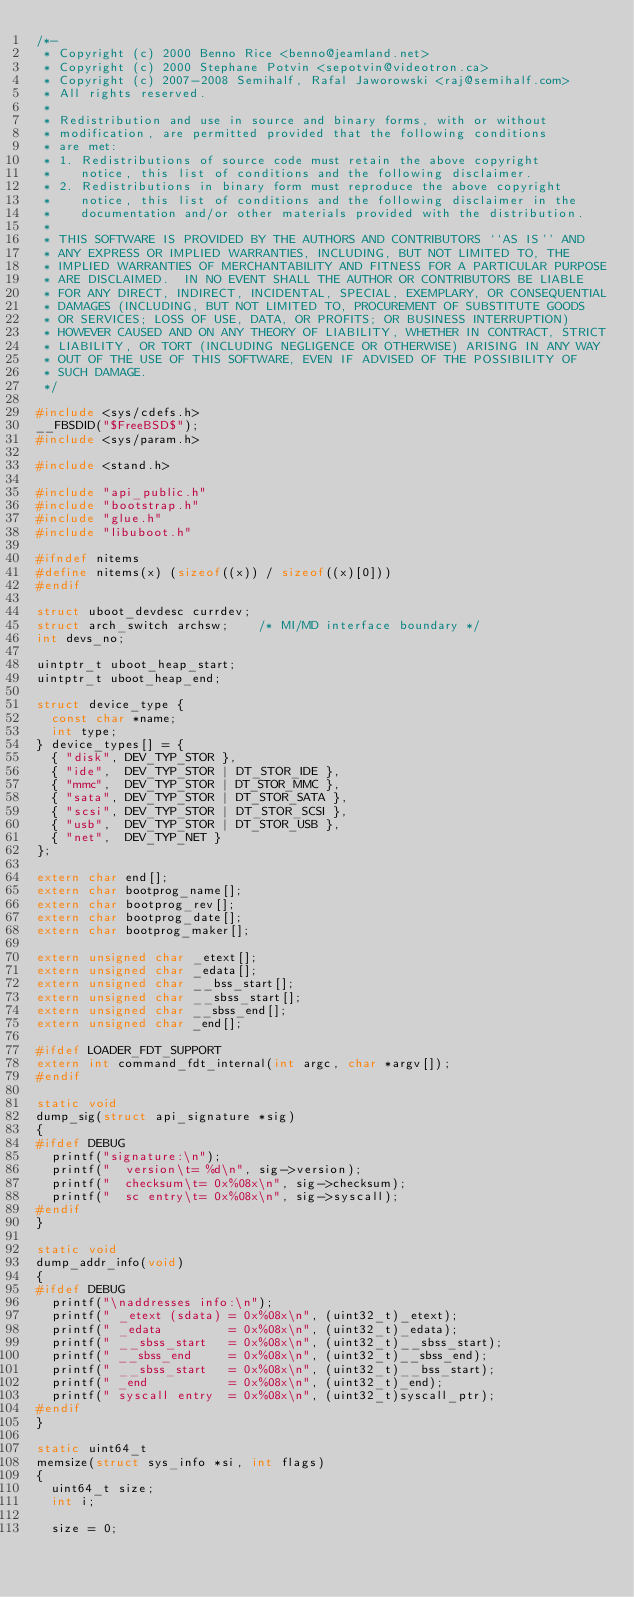Convert code to text. <code><loc_0><loc_0><loc_500><loc_500><_C_>/*-
 * Copyright (c) 2000 Benno Rice <benno@jeamland.net>
 * Copyright (c) 2000 Stephane Potvin <sepotvin@videotron.ca>
 * Copyright (c) 2007-2008 Semihalf, Rafal Jaworowski <raj@semihalf.com>
 * All rights reserved.
 *
 * Redistribution and use in source and binary forms, with or without
 * modification, are permitted provided that the following conditions
 * are met:
 * 1. Redistributions of source code must retain the above copyright
 *    notice, this list of conditions and the following disclaimer.
 * 2. Redistributions in binary form must reproduce the above copyright
 *    notice, this list of conditions and the following disclaimer in the
 *    documentation and/or other materials provided with the distribution.
 *
 * THIS SOFTWARE IS PROVIDED BY THE AUTHORS AND CONTRIBUTORS ``AS IS'' AND
 * ANY EXPRESS OR IMPLIED WARRANTIES, INCLUDING, BUT NOT LIMITED TO, THE
 * IMPLIED WARRANTIES OF MERCHANTABILITY AND FITNESS FOR A PARTICULAR PURPOSE
 * ARE DISCLAIMED.  IN NO EVENT SHALL THE AUTHOR OR CONTRIBUTORS BE LIABLE
 * FOR ANY DIRECT, INDIRECT, INCIDENTAL, SPECIAL, EXEMPLARY, OR CONSEQUENTIAL
 * DAMAGES (INCLUDING, BUT NOT LIMITED TO, PROCUREMENT OF SUBSTITUTE GOODS
 * OR SERVICES; LOSS OF USE, DATA, OR PROFITS; OR BUSINESS INTERRUPTION)
 * HOWEVER CAUSED AND ON ANY THEORY OF LIABILITY, WHETHER IN CONTRACT, STRICT
 * LIABILITY, OR TORT (INCLUDING NEGLIGENCE OR OTHERWISE) ARISING IN ANY WAY
 * OUT OF THE USE OF THIS SOFTWARE, EVEN IF ADVISED OF THE POSSIBILITY OF
 * SUCH DAMAGE.
 */

#include <sys/cdefs.h>
__FBSDID("$FreeBSD$");
#include <sys/param.h>

#include <stand.h>

#include "api_public.h"
#include "bootstrap.h"
#include "glue.h"
#include "libuboot.h"

#ifndef nitems
#define	nitems(x)	(sizeof((x)) / sizeof((x)[0]))
#endif

struct uboot_devdesc currdev;
struct arch_switch archsw;		/* MI/MD interface boundary */
int devs_no;

uintptr_t uboot_heap_start;
uintptr_t uboot_heap_end;

struct device_type { 
	const char *name;
	int type;
} device_types[] = {
	{ "disk", DEV_TYP_STOR },
	{ "ide",  DEV_TYP_STOR | DT_STOR_IDE },
	{ "mmc",  DEV_TYP_STOR | DT_STOR_MMC },
	{ "sata", DEV_TYP_STOR | DT_STOR_SATA },
	{ "scsi", DEV_TYP_STOR | DT_STOR_SCSI },
	{ "usb",  DEV_TYP_STOR | DT_STOR_USB },
	{ "net",  DEV_TYP_NET }
};

extern char end[];
extern char bootprog_name[];
extern char bootprog_rev[];
extern char bootprog_date[];
extern char bootprog_maker[];

extern unsigned char _etext[];
extern unsigned char _edata[];
extern unsigned char __bss_start[];
extern unsigned char __sbss_start[];
extern unsigned char __sbss_end[];
extern unsigned char _end[];

#ifdef LOADER_FDT_SUPPORT
extern int command_fdt_internal(int argc, char *argv[]);
#endif

static void
dump_sig(struct api_signature *sig)
{
#ifdef DEBUG
	printf("signature:\n");
	printf("  version\t= %d\n", sig->version);
	printf("  checksum\t= 0x%08x\n", sig->checksum);
	printf("  sc entry\t= 0x%08x\n", sig->syscall);
#endif
}

static void
dump_addr_info(void)
{
#ifdef DEBUG
	printf("\naddresses info:\n");
	printf(" _etext (sdata) = 0x%08x\n", (uint32_t)_etext);
	printf(" _edata         = 0x%08x\n", (uint32_t)_edata);
	printf(" __sbss_start   = 0x%08x\n", (uint32_t)__sbss_start);
	printf(" __sbss_end     = 0x%08x\n", (uint32_t)__sbss_end);
	printf(" __sbss_start   = 0x%08x\n", (uint32_t)__bss_start);
	printf(" _end           = 0x%08x\n", (uint32_t)_end);
	printf(" syscall entry  = 0x%08x\n", (uint32_t)syscall_ptr);
#endif
}

static uint64_t
memsize(struct sys_info *si, int flags)
{
	uint64_t size;
	int i;

	size = 0;</code> 